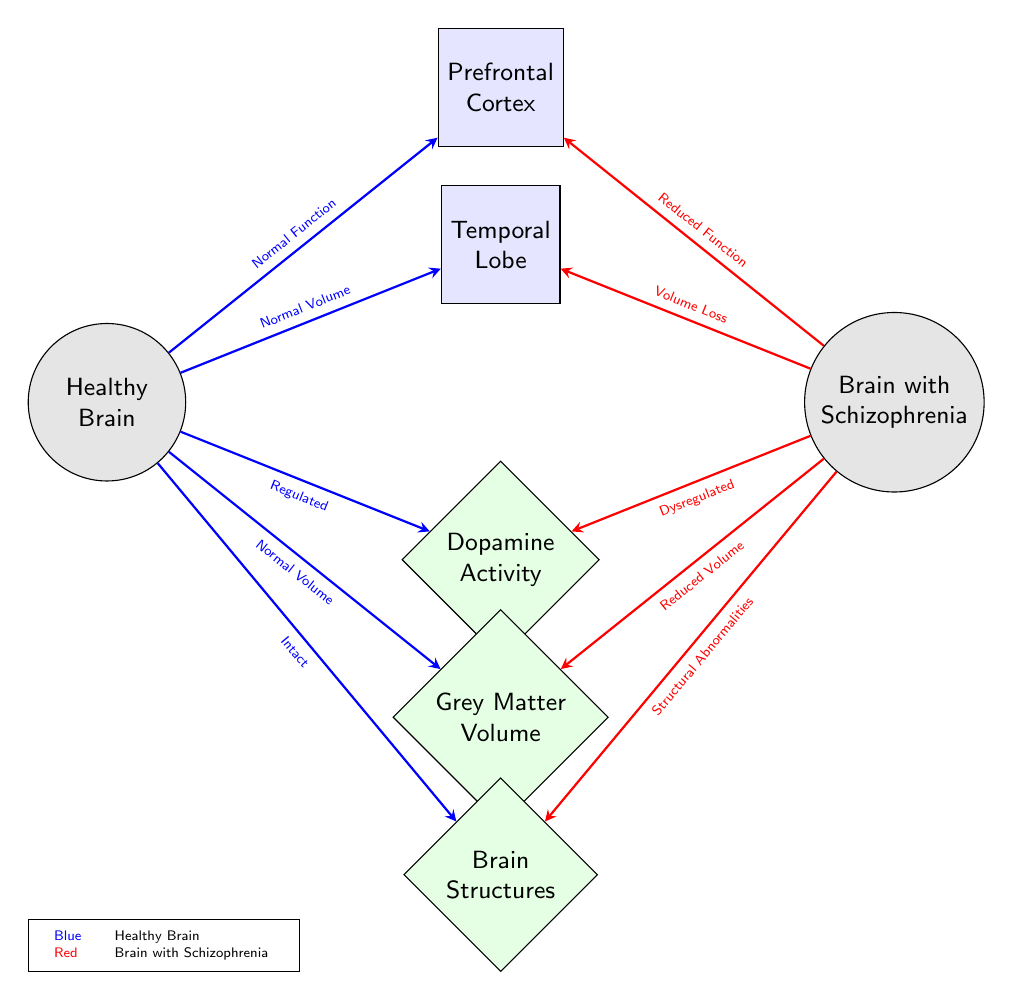What are the two main brain types depicted in the diagram? The diagram depicts a "Healthy Brain" and a "Brain with Schizophrenia" as the two main brain types, clearly labeled at the top of each brain node.
Answer: Healthy Brain, Brain with Schizophrenia What is indicated by the color blue in the diagram? The color blue represents the characteristics associated with the "Healthy Brain," including normal function and volume in the key brain areas.
Answer: Healthy Brain What area shows reduced function in the Brain with Schizophrenia? The "Prefrontal Cortex" shows reduced function as indicated by the red connection coming from the "Brain with Schizophrenia" node, labeled as "Reduced Function."
Answer: Prefrontal Cortex How many properties are represented below the brain types? There are three properties represented below the brain types: Dopamine Activity, Grey Matter Volume, and Brain Structures. Each of these properties is associated with both brain conditions.
Answer: 3 What happens to dopamine activity in the Brain with Schizophrenia? The dopamine activity in the "Brain with Schizophrenia" is indicated as "Dysregulated," contrasting with the "Regulated" condition in the Healthy Brain, demonstrating a significant difference in regulation.
Answer: Dysregulated Which key area shows a loss of volume in the Brain with Schizophrenia? The "Temporal Lobe" shows a "Volume Loss" in the Brain with Schizophrenia as highlighted by the red arrow indicating a specific deviation from normal conditions.
Answer: Temporal Lobe What is the comparative status of grey matter volume between the two brain types? The status of grey matter volume in the "Brain with Schizophrenia" is shown as "Reduced Volume," while the Healthy Brain is indicated to have "Normal Volume," highlighting a significant difference.
Answer: Reduced Volume What structural differences are depicted for the Brain with Schizophrenia? The "Brain Structures" are indicated to have "Structural Abnormalities" in the Brain with Schizophrenia, contrasting with the "Intact" status seen in the Healthy Brain.
Answer: Structural Abnormalities What relationship is shown between the Healthy Brain and the Temporal Lobe? The diagram illustrates that the Healthy Brain has "Normal Volume" in the Temporal Lobe, which is directly connected by a blue arrow labeled as such, indicating a healthy state for this area.
Answer: Normal Volume 